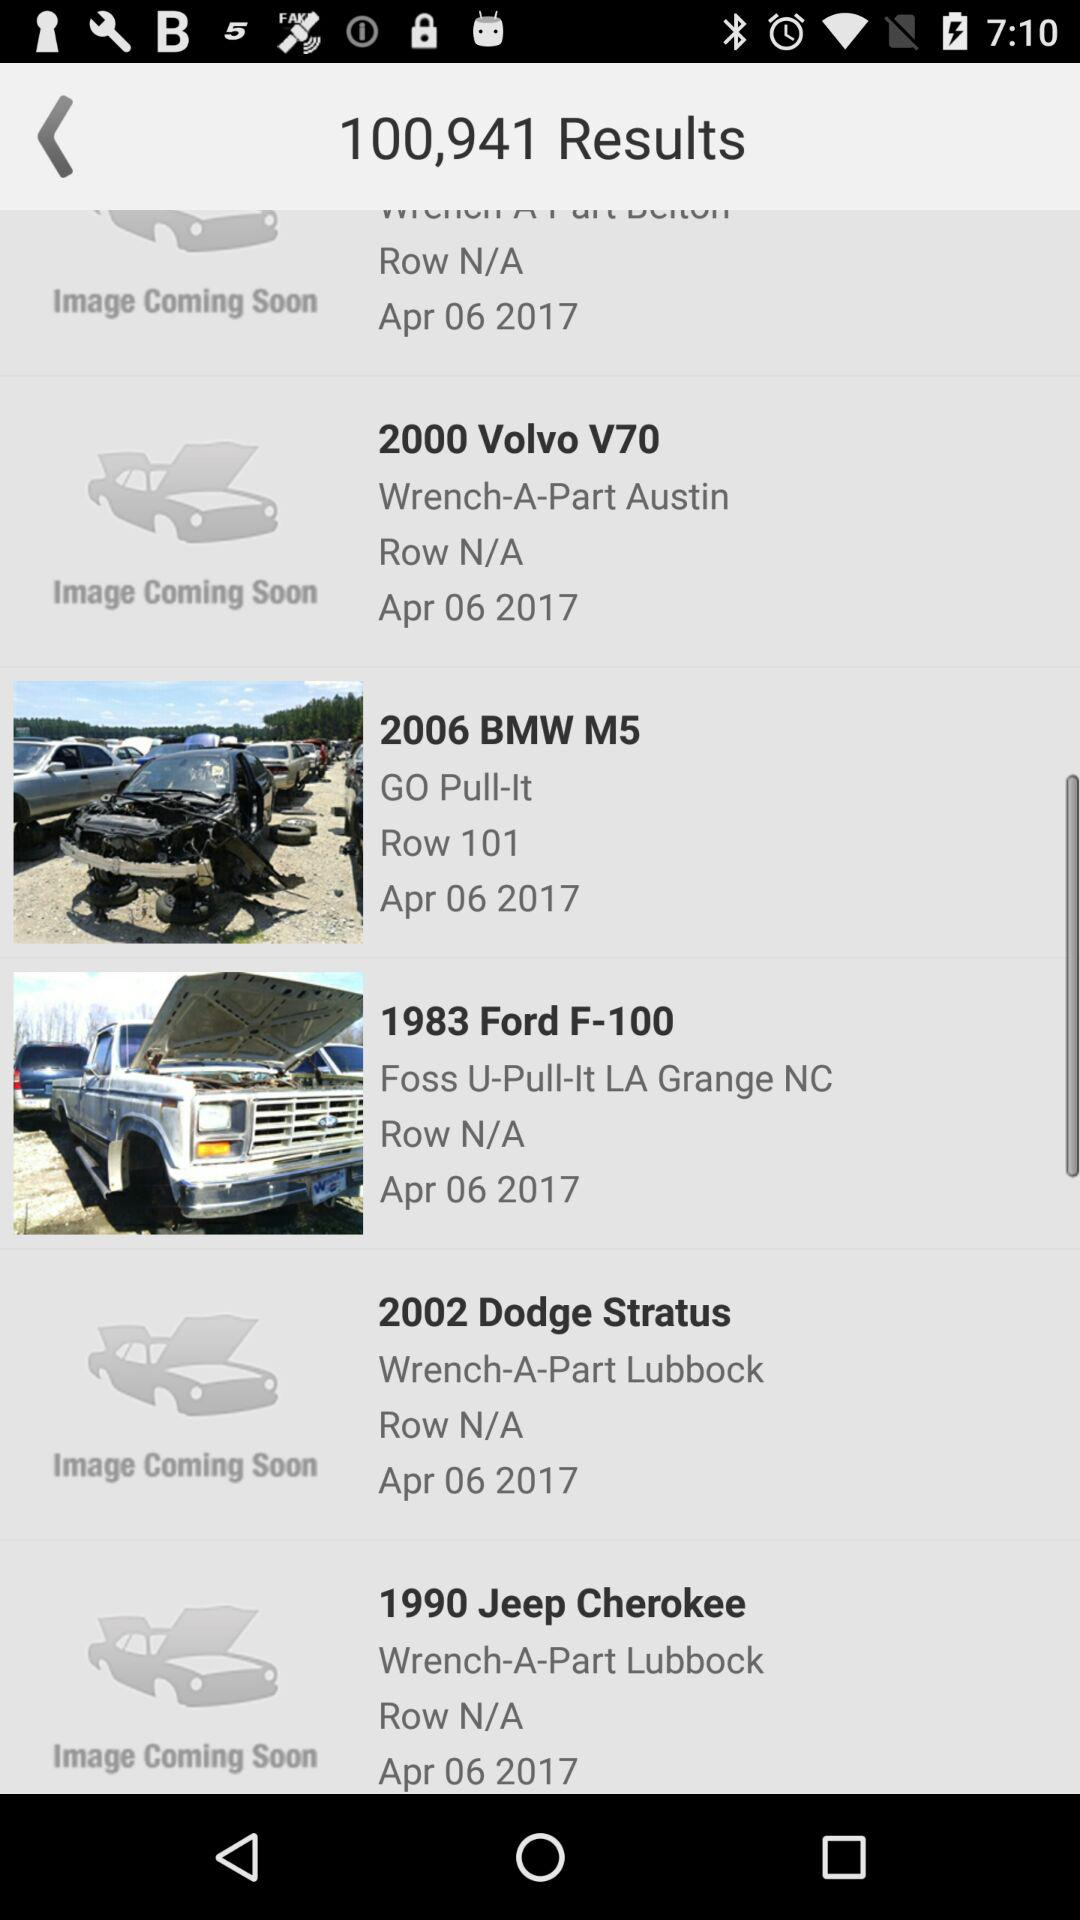What is the number of "Results"? The total number is 100,941. 